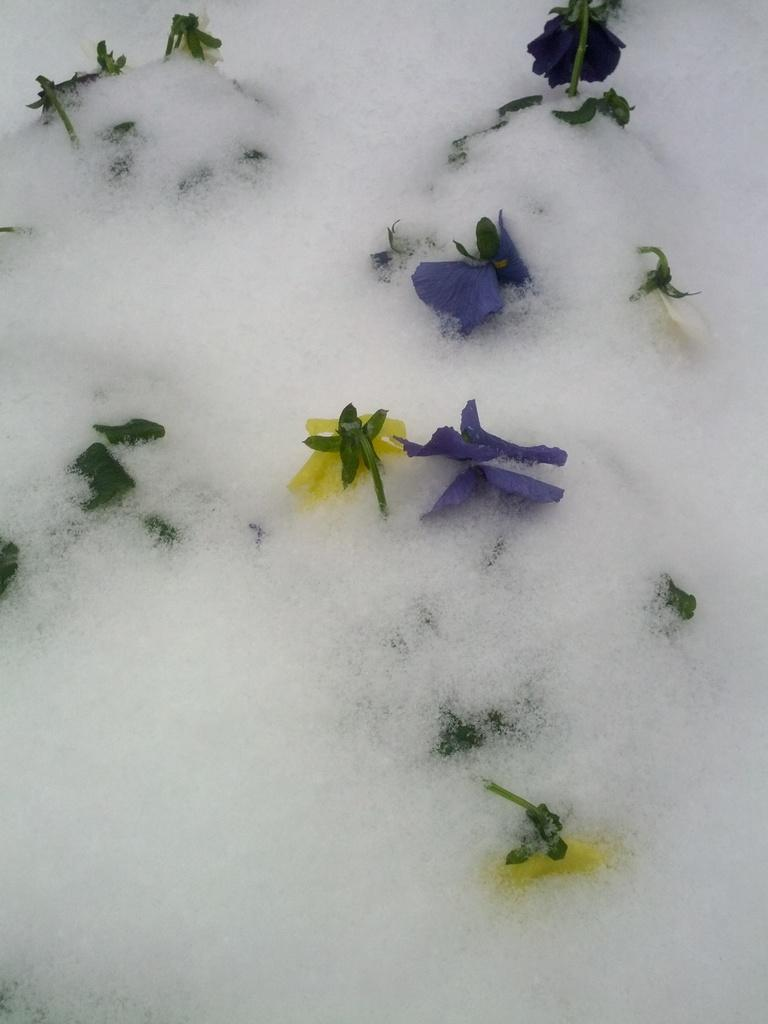What type of plants can be seen in the image? There are flowers in the image. Where are the flowers located? The flowers are in the foam. How many pins are holding the flowers in place in the image? There is no mention of pins in the image, so we cannot determine how many pins are present. 